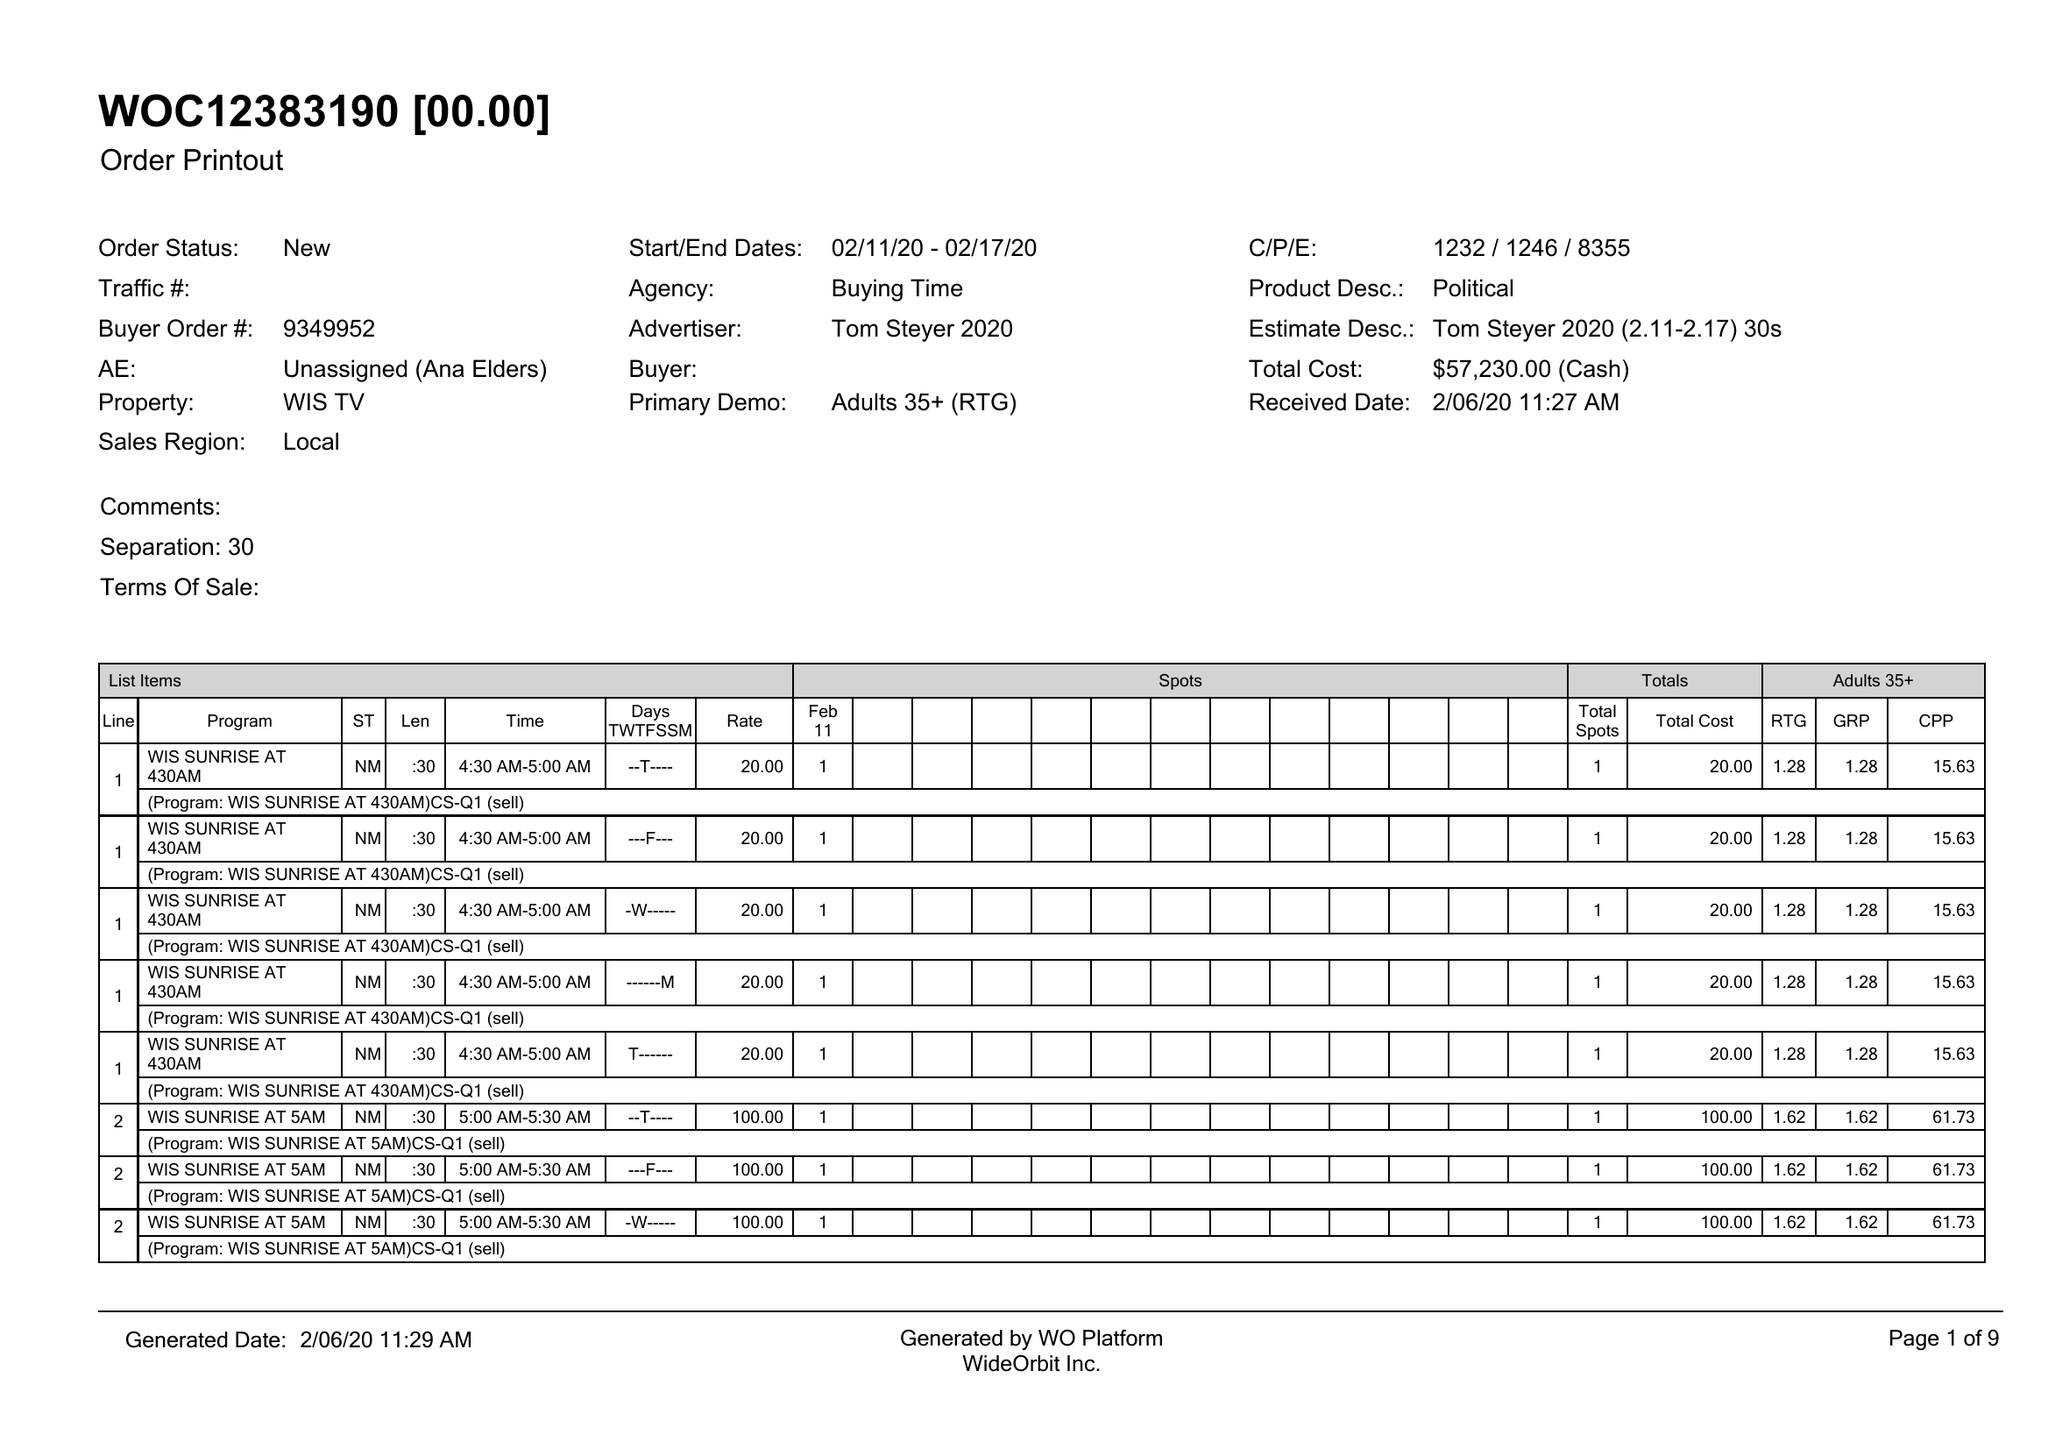What is the value for the flight_from?
Answer the question using a single word or phrase. 02/11/20 